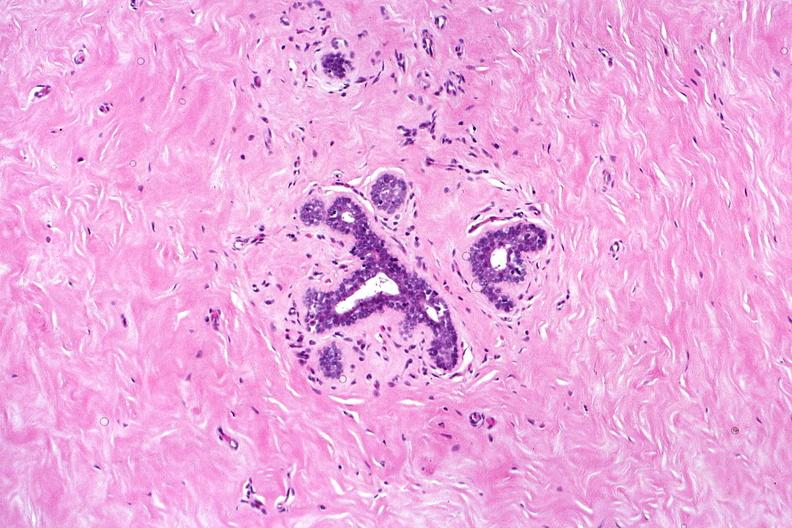s female reproductive present?
Answer the question using a single word or phrase. Yes 